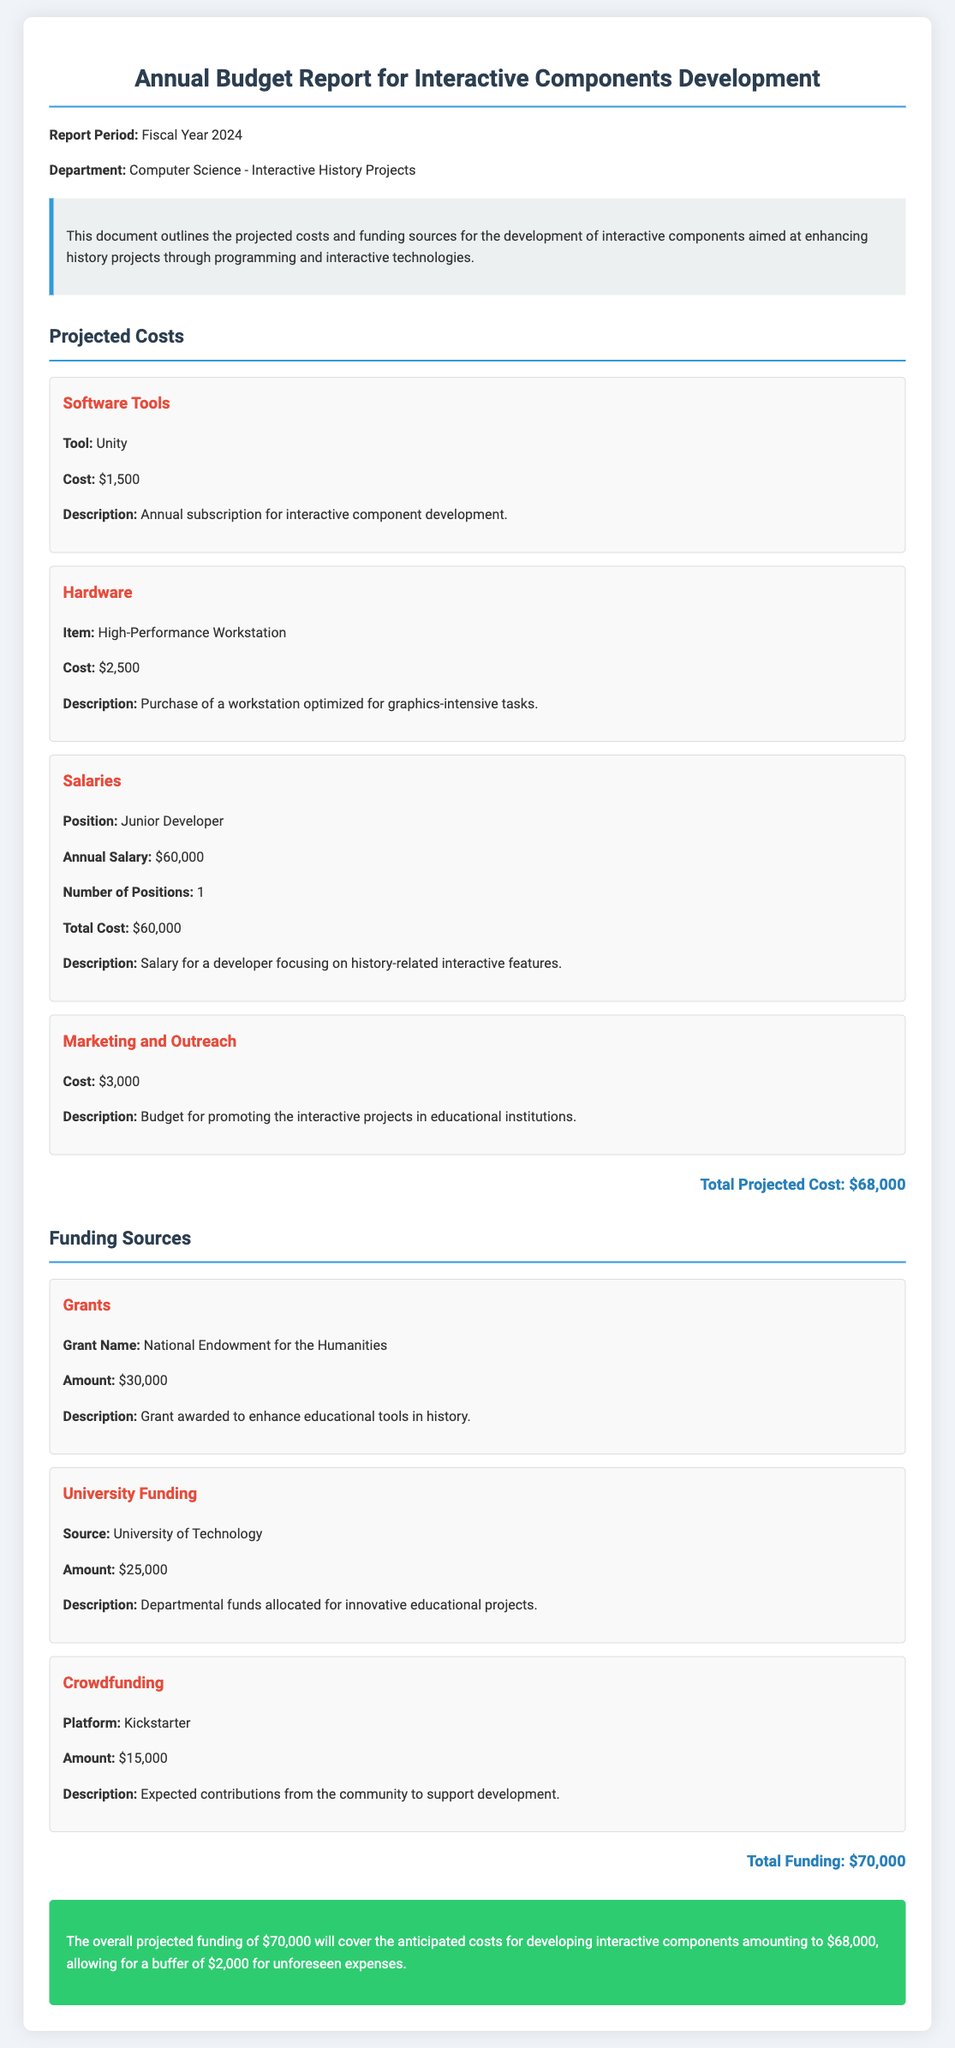What is the total projected cost? The total projected cost is given at the end of the section on projected costs, which totals up the costs listed.
Answer: $68,000 What is the cost for the annual subscription of Unity? This information is detailed under the software tools section, specifying the cost for Unity.
Answer: $1,500 How much funding is expected from crowdfunding? The crowdfunding amount is listed under the funding sources section, specifying the platform and the amount.
Answer: $15,000 What is the annual salary for the Junior Developer? The salary for the Junior Developer is explicitly mentioned in the salaries section of the report.
Answer: $60,000 What is the total funding amount? The total funding amount is the sum of the different funding sources listed in the document, presented at the end of that section.
Answer: $70,000 What is the funding source with the highest amount? This funding source refers to the one that contributes the most financially, as mentioned in the funding sources section.
Answer: Grants What is the buffer amount after considering the projected costs and total funding? This amount represents the difference between total funding and total costs, mentioned in the conclusion.
Answer: $2,000 What is the description for the High-Performance Workstation cost? The description provides details about the purpose and usage of this hardware item.
Answer: Purchase of a workstation optimized for graphics-intensive tasks 